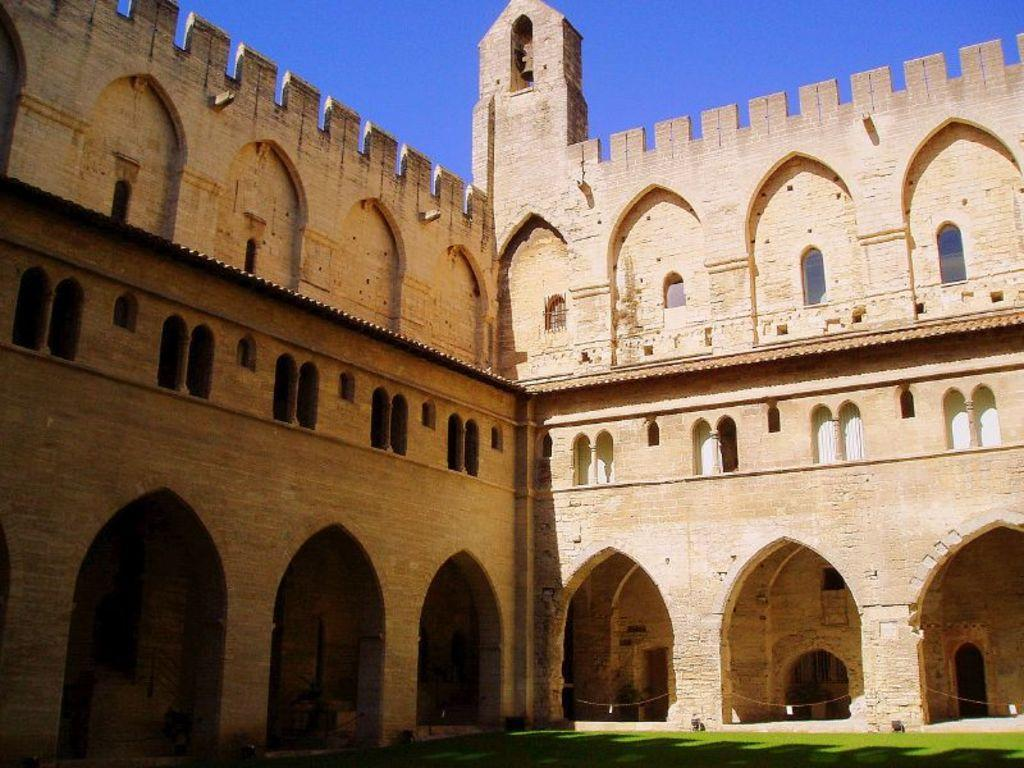What type of structure is in the image? There is a fort in the image. What can be seen attached to the fort? There are ropes in the image. What is visible at the top of the image? The sky is visible at the top of the image. What is visible at the bottom of the image? The ground is visible at the bottom of the image. What type of marble is used to decorate the fort in the image? There is no marble present in the image; it features a fort and ropes. What time of day is the meeting taking place in the image? There is no meeting or indication of time in the image; it only shows a fort and ropes. 